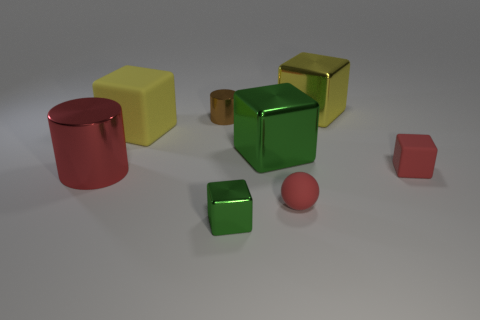There is a cylinder that is on the left side of the small brown cylinder; what is its color?
Provide a short and direct response. Red. Is the number of red cylinders behind the large yellow shiny cube less than the number of green blocks?
Your response must be concise. Yes. Is the material of the small green object the same as the large red object?
Your answer should be very brief. Yes. There is a red rubber object that is the same shape as the big green metallic object; what is its size?
Your answer should be compact. Small. How many objects are either tiny objects that are in front of the large rubber thing or red rubber balls in front of the large yellow metal object?
Offer a very short reply. 3. Are there fewer large shiny cubes than brown cylinders?
Make the answer very short. No. Does the red rubber block have the same size as the green metal cube behind the red ball?
Provide a short and direct response. No. What number of metal objects are either big cubes or large red cylinders?
Keep it short and to the point. 3. Are there more objects than tiny brown shiny cylinders?
Offer a terse response. Yes. What is the size of the cube that is the same color as the big matte thing?
Give a very brief answer. Large. 